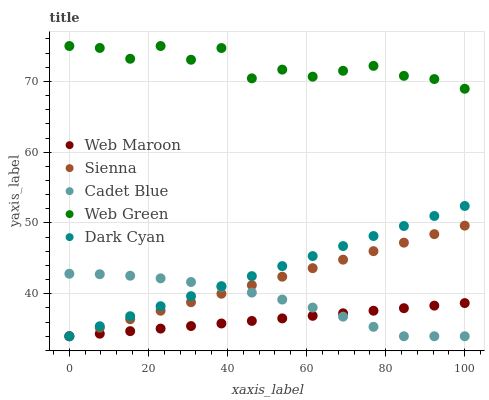Does Web Maroon have the minimum area under the curve?
Answer yes or no. Yes. Does Web Green have the maximum area under the curve?
Answer yes or no. Yes. Does Dark Cyan have the minimum area under the curve?
Answer yes or no. No. Does Dark Cyan have the maximum area under the curve?
Answer yes or no. No. Is Web Maroon the smoothest?
Answer yes or no. Yes. Is Web Green the roughest?
Answer yes or no. Yes. Is Dark Cyan the smoothest?
Answer yes or no. No. Is Dark Cyan the roughest?
Answer yes or no. No. Does Sienna have the lowest value?
Answer yes or no. Yes. Does Web Green have the lowest value?
Answer yes or no. No. Does Web Green have the highest value?
Answer yes or no. Yes. Does Dark Cyan have the highest value?
Answer yes or no. No. Is Sienna less than Web Green?
Answer yes or no. Yes. Is Web Green greater than Web Maroon?
Answer yes or no. Yes. Does Sienna intersect Web Maroon?
Answer yes or no. Yes. Is Sienna less than Web Maroon?
Answer yes or no. No. Is Sienna greater than Web Maroon?
Answer yes or no. No. Does Sienna intersect Web Green?
Answer yes or no. No. 